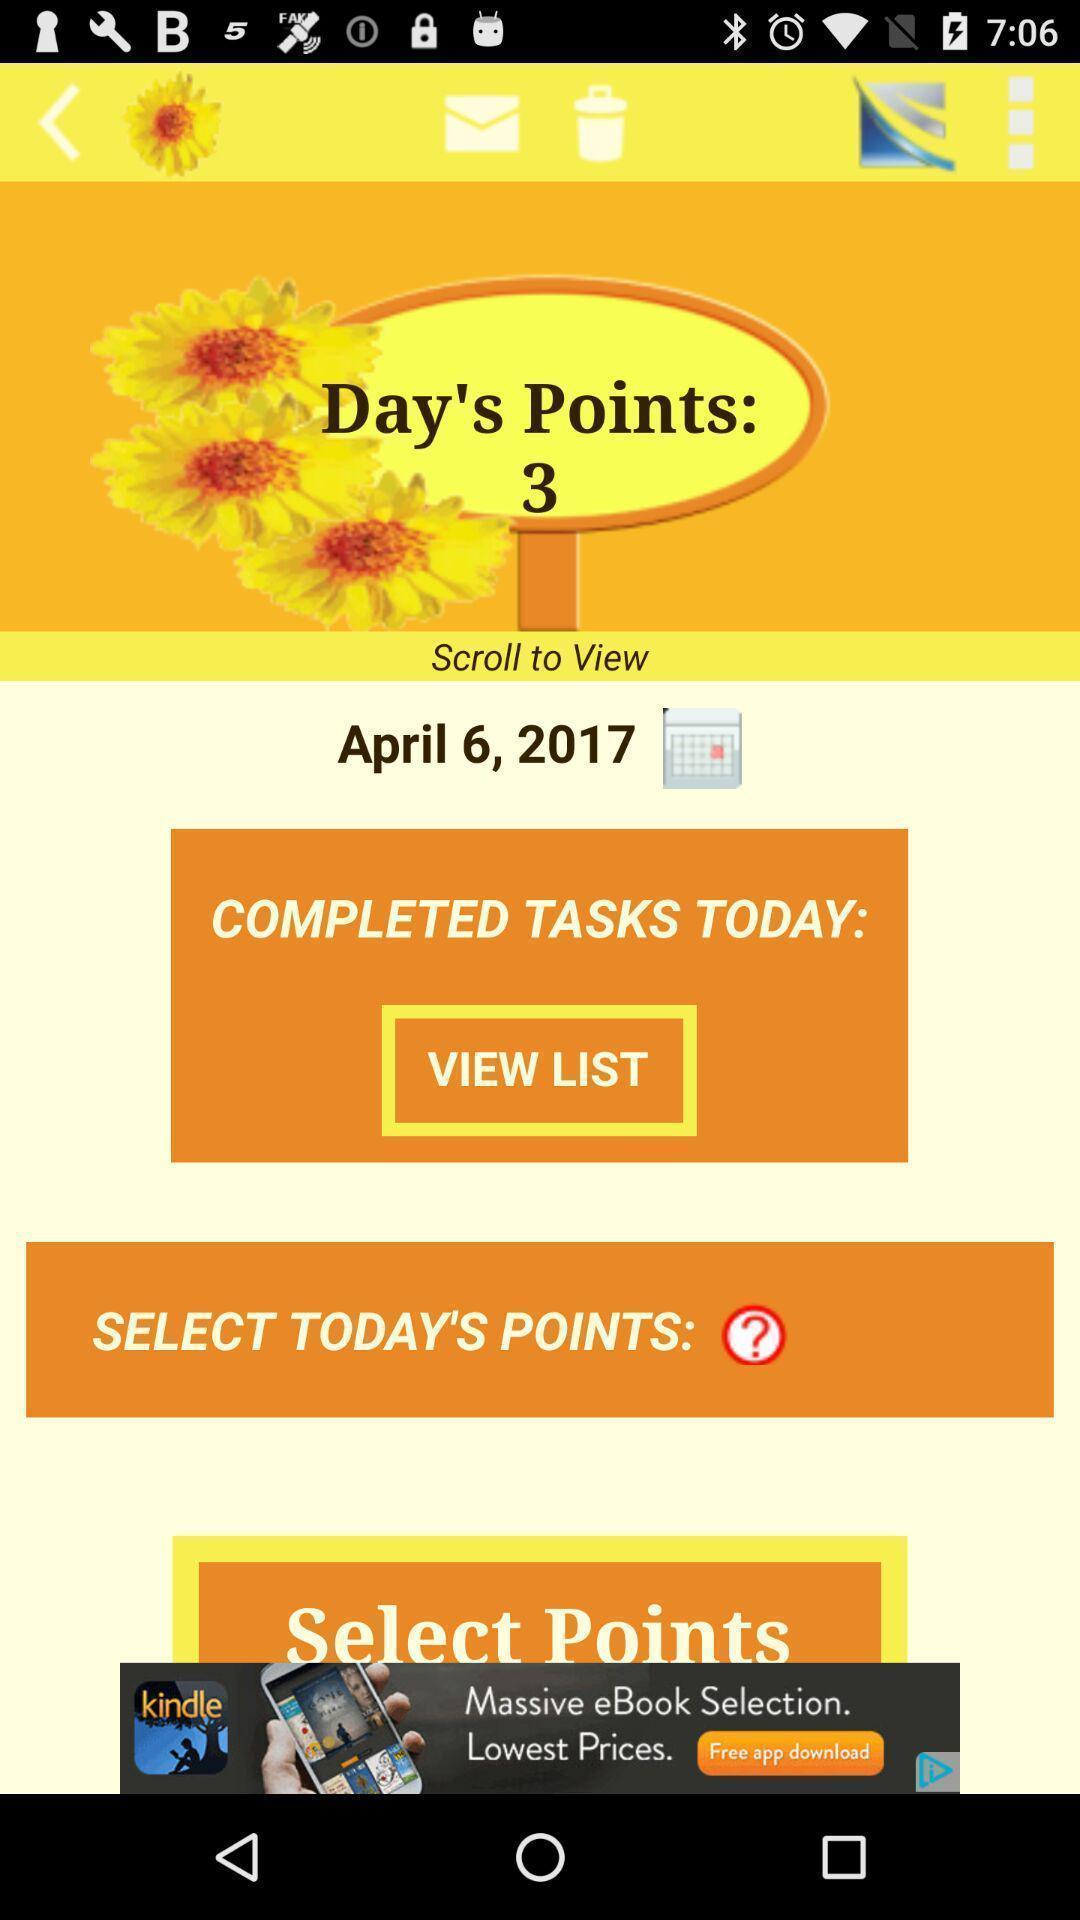Tell me about the visual elements in this screen capture. Screen showing points gained of a day planner app. 